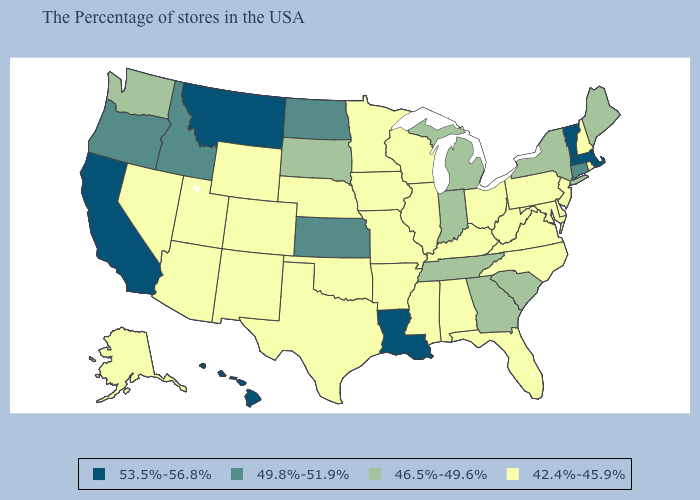What is the lowest value in the USA?
Short answer required. 42.4%-45.9%. Name the states that have a value in the range 53.5%-56.8%?
Quick response, please. Massachusetts, Vermont, Louisiana, Montana, California, Hawaii. Name the states that have a value in the range 46.5%-49.6%?
Quick response, please. Maine, New York, South Carolina, Georgia, Michigan, Indiana, Tennessee, South Dakota, Washington. Which states hav the highest value in the South?
Give a very brief answer. Louisiana. Name the states that have a value in the range 49.8%-51.9%?
Be succinct. Connecticut, Kansas, North Dakota, Idaho, Oregon. Does the first symbol in the legend represent the smallest category?
Concise answer only. No. Which states have the lowest value in the USA?
Give a very brief answer. Rhode Island, New Hampshire, New Jersey, Delaware, Maryland, Pennsylvania, Virginia, North Carolina, West Virginia, Ohio, Florida, Kentucky, Alabama, Wisconsin, Illinois, Mississippi, Missouri, Arkansas, Minnesota, Iowa, Nebraska, Oklahoma, Texas, Wyoming, Colorado, New Mexico, Utah, Arizona, Nevada, Alaska. Does Iowa have the same value as Vermont?
Short answer required. No. Does Connecticut have the lowest value in the Northeast?
Be succinct. No. Does Hawaii have the highest value in the West?
Keep it brief. Yes. What is the value of Ohio?
Be succinct. 42.4%-45.9%. Is the legend a continuous bar?
Quick response, please. No. Does Tennessee have the lowest value in the USA?
Answer briefly. No. Does Kentucky have the same value as Texas?
Be succinct. Yes. Name the states that have a value in the range 46.5%-49.6%?
Give a very brief answer. Maine, New York, South Carolina, Georgia, Michigan, Indiana, Tennessee, South Dakota, Washington. 